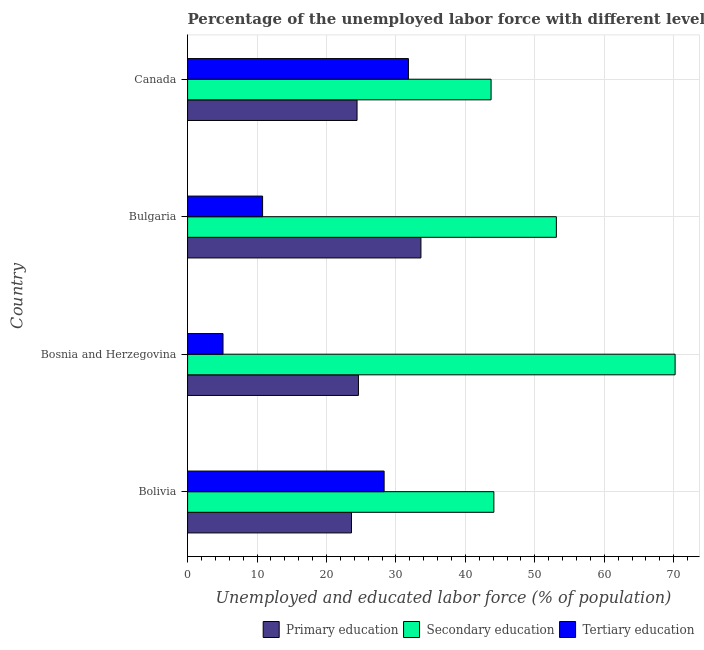How many different coloured bars are there?
Ensure brevity in your answer.  3. Are the number of bars per tick equal to the number of legend labels?
Your answer should be very brief. Yes. Are the number of bars on each tick of the Y-axis equal?
Give a very brief answer. Yes. How many bars are there on the 2nd tick from the top?
Provide a short and direct response. 3. How many bars are there on the 2nd tick from the bottom?
Make the answer very short. 3. What is the label of the 3rd group of bars from the top?
Keep it short and to the point. Bosnia and Herzegovina. In how many cases, is the number of bars for a given country not equal to the number of legend labels?
Provide a short and direct response. 0. What is the percentage of labor force who received tertiary education in Bolivia?
Offer a very short reply. 28.3. Across all countries, what is the maximum percentage of labor force who received secondary education?
Offer a very short reply. 70.2. Across all countries, what is the minimum percentage of labor force who received secondary education?
Provide a short and direct response. 43.7. In which country was the percentage of labor force who received secondary education maximum?
Your answer should be very brief. Bosnia and Herzegovina. In which country was the percentage of labor force who received secondary education minimum?
Your answer should be compact. Canada. What is the total percentage of labor force who received tertiary education in the graph?
Provide a succinct answer. 76. What is the difference between the percentage of labor force who received primary education in Bolivia and that in Bosnia and Herzegovina?
Keep it short and to the point. -1. What is the difference between the percentage of labor force who received tertiary education in Canada and the percentage of labor force who received primary education in Bosnia and Herzegovina?
Your answer should be compact. 7.2. What is the average percentage of labor force who received primary education per country?
Provide a short and direct response. 26.55. What is the difference between the percentage of labor force who received primary education and percentage of labor force who received tertiary education in Canada?
Your response must be concise. -7.4. In how many countries, is the percentage of labor force who received tertiary education greater than 12 %?
Provide a succinct answer. 2. What is the ratio of the percentage of labor force who received tertiary education in Bolivia to that in Bulgaria?
Your answer should be compact. 2.62. Is the percentage of labor force who received secondary education in Bolivia less than that in Bulgaria?
Your answer should be compact. Yes. Is the sum of the percentage of labor force who received secondary education in Bosnia and Herzegovina and Canada greater than the maximum percentage of labor force who received tertiary education across all countries?
Offer a very short reply. Yes. What does the 1st bar from the top in Canada represents?
Give a very brief answer. Tertiary education. Is it the case that in every country, the sum of the percentage of labor force who received primary education and percentage of labor force who received secondary education is greater than the percentage of labor force who received tertiary education?
Keep it short and to the point. Yes. How many countries are there in the graph?
Make the answer very short. 4. What is the difference between two consecutive major ticks on the X-axis?
Provide a succinct answer. 10. Are the values on the major ticks of X-axis written in scientific E-notation?
Provide a succinct answer. No. What is the title of the graph?
Provide a succinct answer. Percentage of the unemployed labor force with different levels of education in countries. What is the label or title of the X-axis?
Offer a very short reply. Unemployed and educated labor force (% of population). What is the label or title of the Y-axis?
Give a very brief answer. Country. What is the Unemployed and educated labor force (% of population) in Primary education in Bolivia?
Keep it short and to the point. 23.6. What is the Unemployed and educated labor force (% of population) of Secondary education in Bolivia?
Make the answer very short. 44.1. What is the Unemployed and educated labor force (% of population) in Tertiary education in Bolivia?
Your response must be concise. 28.3. What is the Unemployed and educated labor force (% of population) in Primary education in Bosnia and Herzegovina?
Give a very brief answer. 24.6. What is the Unemployed and educated labor force (% of population) of Secondary education in Bosnia and Herzegovina?
Offer a terse response. 70.2. What is the Unemployed and educated labor force (% of population) in Tertiary education in Bosnia and Herzegovina?
Provide a succinct answer. 5.1. What is the Unemployed and educated labor force (% of population) in Primary education in Bulgaria?
Your answer should be very brief. 33.6. What is the Unemployed and educated labor force (% of population) in Secondary education in Bulgaria?
Make the answer very short. 53.1. What is the Unemployed and educated labor force (% of population) of Tertiary education in Bulgaria?
Make the answer very short. 10.8. What is the Unemployed and educated labor force (% of population) in Primary education in Canada?
Make the answer very short. 24.4. What is the Unemployed and educated labor force (% of population) in Secondary education in Canada?
Provide a short and direct response. 43.7. What is the Unemployed and educated labor force (% of population) in Tertiary education in Canada?
Keep it short and to the point. 31.8. Across all countries, what is the maximum Unemployed and educated labor force (% of population) of Primary education?
Your answer should be compact. 33.6. Across all countries, what is the maximum Unemployed and educated labor force (% of population) of Secondary education?
Ensure brevity in your answer.  70.2. Across all countries, what is the maximum Unemployed and educated labor force (% of population) of Tertiary education?
Offer a terse response. 31.8. Across all countries, what is the minimum Unemployed and educated labor force (% of population) of Primary education?
Your response must be concise. 23.6. Across all countries, what is the minimum Unemployed and educated labor force (% of population) in Secondary education?
Your answer should be very brief. 43.7. Across all countries, what is the minimum Unemployed and educated labor force (% of population) in Tertiary education?
Your response must be concise. 5.1. What is the total Unemployed and educated labor force (% of population) of Primary education in the graph?
Make the answer very short. 106.2. What is the total Unemployed and educated labor force (% of population) in Secondary education in the graph?
Your answer should be compact. 211.1. What is the total Unemployed and educated labor force (% of population) of Tertiary education in the graph?
Provide a succinct answer. 76. What is the difference between the Unemployed and educated labor force (% of population) in Secondary education in Bolivia and that in Bosnia and Herzegovina?
Provide a short and direct response. -26.1. What is the difference between the Unemployed and educated labor force (% of population) in Tertiary education in Bolivia and that in Bosnia and Herzegovina?
Offer a very short reply. 23.2. What is the difference between the Unemployed and educated labor force (% of population) in Secondary education in Bolivia and that in Bulgaria?
Keep it short and to the point. -9. What is the difference between the Unemployed and educated labor force (% of population) in Tertiary education in Bolivia and that in Bulgaria?
Provide a succinct answer. 17.5. What is the difference between the Unemployed and educated labor force (% of population) in Primary education in Bosnia and Herzegovina and that in Bulgaria?
Your response must be concise. -9. What is the difference between the Unemployed and educated labor force (% of population) in Tertiary education in Bosnia and Herzegovina and that in Bulgaria?
Your answer should be compact. -5.7. What is the difference between the Unemployed and educated labor force (% of population) of Primary education in Bosnia and Herzegovina and that in Canada?
Offer a terse response. 0.2. What is the difference between the Unemployed and educated labor force (% of population) of Secondary education in Bosnia and Herzegovina and that in Canada?
Your answer should be compact. 26.5. What is the difference between the Unemployed and educated labor force (% of population) of Tertiary education in Bosnia and Herzegovina and that in Canada?
Ensure brevity in your answer.  -26.7. What is the difference between the Unemployed and educated labor force (% of population) of Secondary education in Bulgaria and that in Canada?
Provide a succinct answer. 9.4. What is the difference between the Unemployed and educated labor force (% of population) of Tertiary education in Bulgaria and that in Canada?
Give a very brief answer. -21. What is the difference between the Unemployed and educated labor force (% of population) of Primary education in Bolivia and the Unemployed and educated labor force (% of population) of Secondary education in Bosnia and Herzegovina?
Offer a very short reply. -46.6. What is the difference between the Unemployed and educated labor force (% of population) in Primary education in Bolivia and the Unemployed and educated labor force (% of population) in Secondary education in Bulgaria?
Make the answer very short. -29.5. What is the difference between the Unemployed and educated labor force (% of population) in Secondary education in Bolivia and the Unemployed and educated labor force (% of population) in Tertiary education in Bulgaria?
Ensure brevity in your answer.  33.3. What is the difference between the Unemployed and educated labor force (% of population) in Primary education in Bolivia and the Unemployed and educated labor force (% of population) in Secondary education in Canada?
Ensure brevity in your answer.  -20.1. What is the difference between the Unemployed and educated labor force (% of population) of Secondary education in Bolivia and the Unemployed and educated labor force (% of population) of Tertiary education in Canada?
Provide a succinct answer. 12.3. What is the difference between the Unemployed and educated labor force (% of population) of Primary education in Bosnia and Herzegovina and the Unemployed and educated labor force (% of population) of Secondary education in Bulgaria?
Offer a terse response. -28.5. What is the difference between the Unemployed and educated labor force (% of population) of Primary education in Bosnia and Herzegovina and the Unemployed and educated labor force (% of population) of Tertiary education in Bulgaria?
Offer a terse response. 13.8. What is the difference between the Unemployed and educated labor force (% of population) in Secondary education in Bosnia and Herzegovina and the Unemployed and educated labor force (% of population) in Tertiary education in Bulgaria?
Make the answer very short. 59.4. What is the difference between the Unemployed and educated labor force (% of population) of Primary education in Bosnia and Herzegovina and the Unemployed and educated labor force (% of population) of Secondary education in Canada?
Offer a terse response. -19.1. What is the difference between the Unemployed and educated labor force (% of population) in Secondary education in Bosnia and Herzegovina and the Unemployed and educated labor force (% of population) in Tertiary education in Canada?
Make the answer very short. 38.4. What is the difference between the Unemployed and educated labor force (% of population) in Primary education in Bulgaria and the Unemployed and educated labor force (% of population) in Secondary education in Canada?
Offer a terse response. -10.1. What is the difference between the Unemployed and educated labor force (% of population) of Primary education in Bulgaria and the Unemployed and educated labor force (% of population) of Tertiary education in Canada?
Make the answer very short. 1.8. What is the difference between the Unemployed and educated labor force (% of population) of Secondary education in Bulgaria and the Unemployed and educated labor force (% of population) of Tertiary education in Canada?
Keep it short and to the point. 21.3. What is the average Unemployed and educated labor force (% of population) of Primary education per country?
Ensure brevity in your answer.  26.55. What is the average Unemployed and educated labor force (% of population) in Secondary education per country?
Your response must be concise. 52.77. What is the difference between the Unemployed and educated labor force (% of population) of Primary education and Unemployed and educated labor force (% of population) of Secondary education in Bolivia?
Your answer should be very brief. -20.5. What is the difference between the Unemployed and educated labor force (% of population) of Primary education and Unemployed and educated labor force (% of population) of Tertiary education in Bolivia?
Your answer should be very brief. -4.7. What is the difference between the Unemployed and educated labor force (% of population) in Primary education and Unemployed and educated labor force (% of population) in Secondary education in Bosnia and Herzegovina?
Your answer should be very brief. -45.6. What is the difference between the Unemployed and educated labor force (% of population) of Secondary education and Unemployed and educated labor force (% of population) of Tertiary education in Bosnia and Herzegovina?
Your response must be concise. 65.1. What is the difference between the Unemployed and educated labor force (% of population) in Primary education and Unemployed and educated labor force (% of population) in Secondary education in Bulgaria?
Your answer should be compact. -19.5. What is the difference between the Unemployed and educated labor force (% of population) of Primary education and Unemployed and educated labor force (% of population) of Tertiary education in Bulgaria?
Provide a succinct answer. 22.8. What is the difference between the Unemployed and educated labor force (% of population) of Secondary education and Unemployed and educated labor force (% of population) of Tertiary education in Bulgaria?
Your response must be concise. 42.3. What is the difference between the Unemployed and educated labor force (% of population) of Primary education and Unemployed and educated labor force (% of population) of Secondary education in Canada?
Your response must be concise. -19.3. What is the difference between the Unemployed and educated labor force (% of population) of Primary education and Unemployed and educated labor force (% of population) of Tertiary education in Canada?
Your answer should be very brief. -7.4. What is the ratio of the Unemployed and educated labor force (% of population) of Primary education in Bolivia to that in Bosnia and Herzegovina?
Keep it short and to the point. 0.96. What is the ratio of the Unemployed and educated labor force (% of population) in Secondary education in Bolivia to that in Bosnia and Herzegovina?
Make the answer very short. 0.63. What is the ratio of the Unemployed and educated labor force (% of population) of Tertiary education in Bolivia to that in Bosnia and Herzegovina?
Ensure brevity in your answer.  5.55. What is the ratio of the Unemployed and educated labor force (% of population) in Primary education in Bolivia to that in Bulgaria?
Your answer should be very brief. 0.7. What is the ratio of the Unemployed and educated labor force (% of population) of Secondary education in Bolivia to that in Bulgaria?
Your answer should be very brief. 0.83. What is the ratio of the Unemployed and educated labor force (% of population) in Tertiary education in Bolivia to that in Bulgaria?
Your answer should be compact. 2.62. What is the ratio of the Unemployed and educated labor force (% of population) in Primary education in Bolivia to that in Canada?
Your answer should be compact. 0.97. What is the ratio of the Unemployed and educated labor force (% of population) of Secondary education in Bolivia to that in Canada?
Offer a very short reply. 1.01. What is the ratio of the Unemployed and educated labor force (% of population) of Tertiary education in Bolivia to that in Canada?
Keep it short and to the point. 0.89. What is the ratio of the Unemployed and educated labor force (% of population) of Primary education in Bosnia and Herzegovina to that in Bulgaria?
Give a very brief answer. 0.73. What is the ratio of the Unemployed and educated labor force (% of population) of Secondary education in Bosnia and Herzegovina to that in Bulgaria?
Your answer should be compact. 1.32. What is the ratio of the Unemployed and educated labor force (% of population) of Tertiary education in Bosnia and Herzegovina to that in Bulgaria?
Keep it short and to the point. 0.47. What is the ratio of the Unemployed and educated labor force (% of population) of Primary education in Bosnia and Herzegovina to that in Canada?
Offer a terse response. 1.01. What is the ratio of the Unemployed and educated labor force (% of population) in Secondary education in Bosnia and Herzegovina to that in Canada?
Provide a succinct answer. 1.61. What is the ratio of the Unemployed and educated labor force (% of population) of Tertiary education in Bosnia and Herzegovina to that in Canada?
Ensure brevity in your answer.  0.16. What is the ratio of the Unemployed and educated labor force (% of population) of Primary education in Bulgaria to that in Canada?
Offer a terse response. 1.38. What is the ratio of the Unemployed and educated labor force (% of population) of Secondary education in Bulgaria to that in Canada?
Provide a short and direct response. 1.22. What is the ratio of the Unemployed and educated labor force (% of population) in Tertiary education in Bulgaria to that in Canada?
Provide a succinct answer. 0.34. What is the difference between the highest and the second highest Unemployed and educated labor force (% of population) in Secondary education?
Offer a terse response. 17.1. What is the difference between the highest and the second highest Unemployed and educated labor force (% of population) of Tertiary education?
Offer a terse response. 3.5. What is the difference between the highest and the lowest Unemployed and educated labor force (% of population) in Primary education?
Your response must be concise. 10. What is the difference between the highest and the lowest Unemployed and educated labor force (% of population) in Secondary education?
Give a very brief answer. 26.5. What is the difference between the highest and the lowest Unemployed and educated labor force (% of population) in Tertiary education?
Provide a short and direct response. 26.7. 